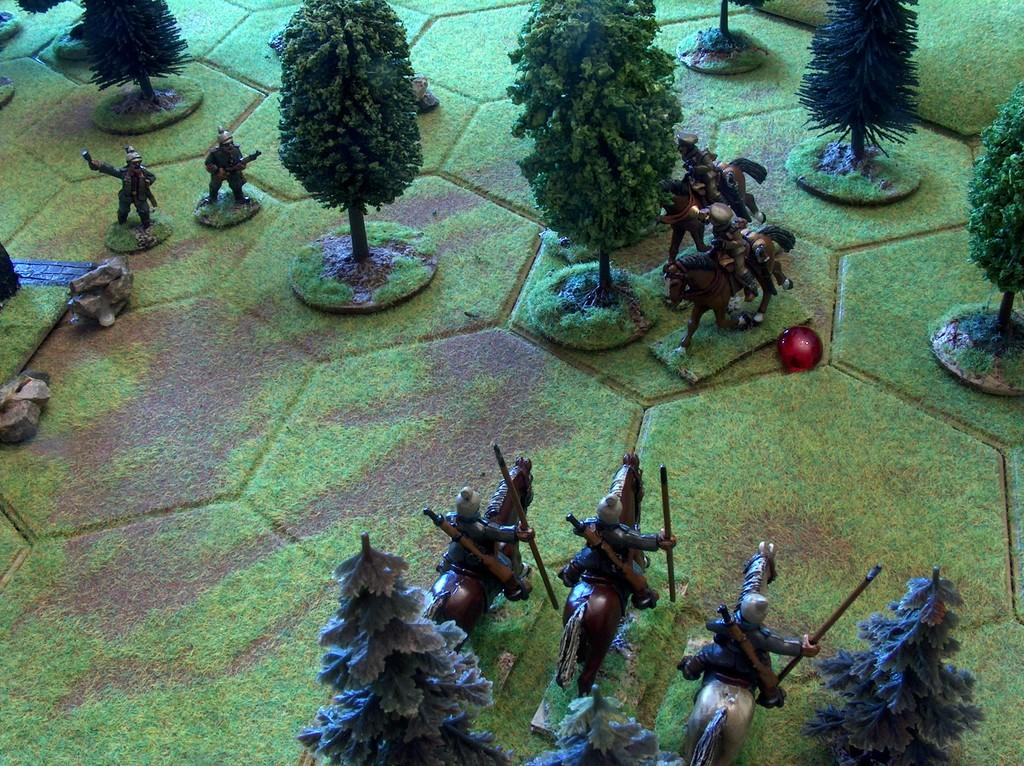What is the main theme or subject of the image? The image appears to be related to a project. What type of vegetation is present in the image? There are small trees in the image. What type of animals can be seen in the image? There are images of soldiers and horses in the image. How are the images of soldiers and horses arranged in the image? The images of soldiers and horses are interspersed between the small trees. What type of poison is being used by the mother in the image? There is no mother or poison present in the image; it features small trees, images of soldiers, and horses. 